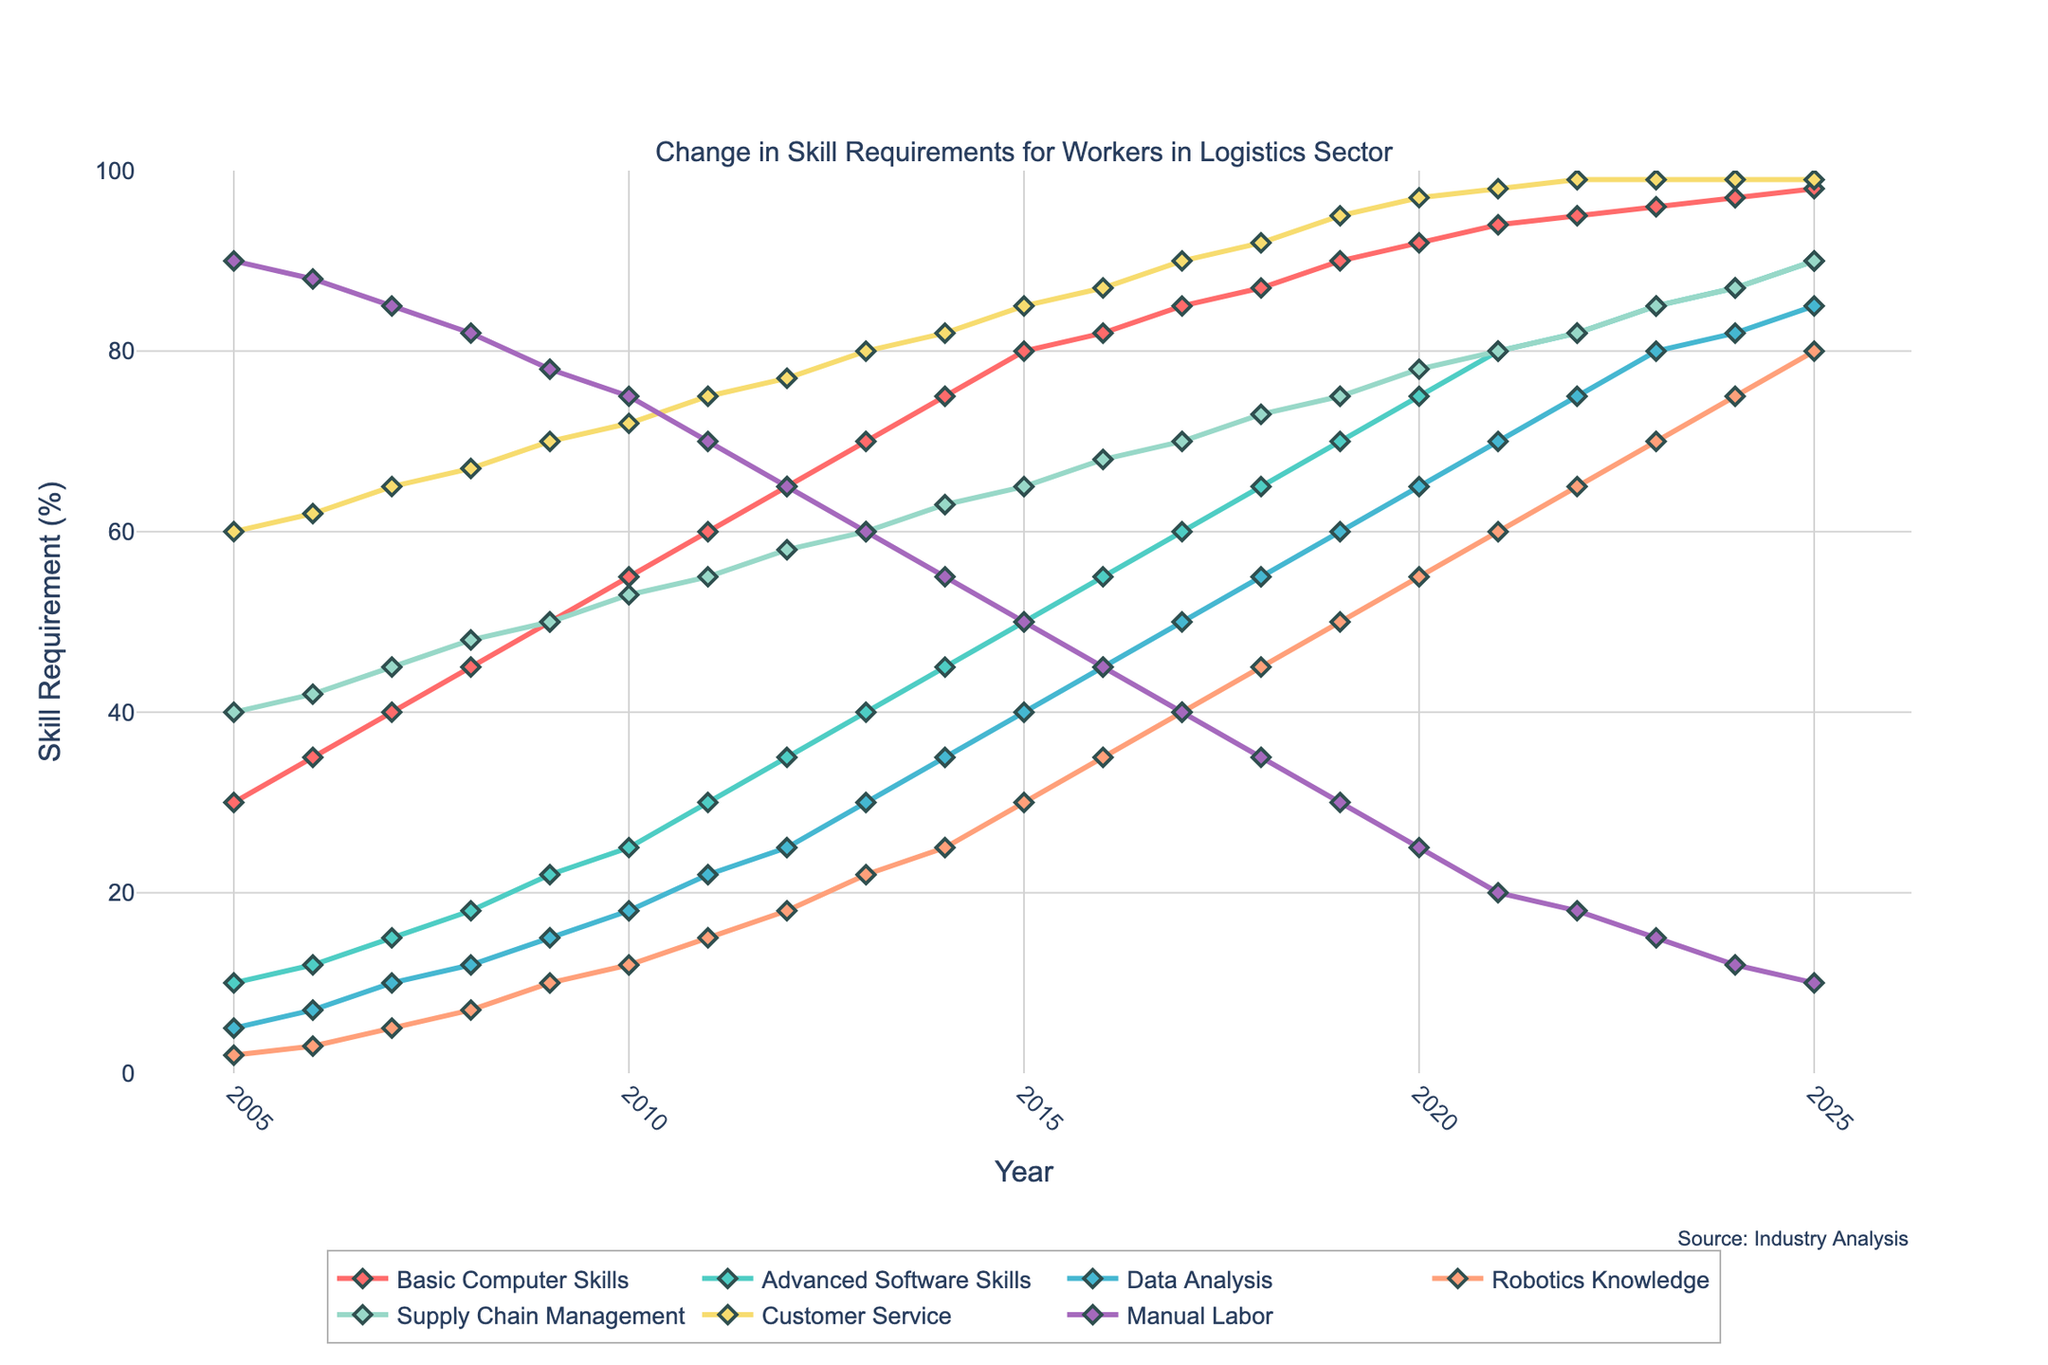What skill showed the most significant increase from 2005 to 2025? By visually inspecting the figure, observe the change in the height of the lines for each skill from 2005 to 2025. The skill with the steepest increase indicates the most significant growth.
Answer: Advanced Software Skills Which skill had the slowest growth in its requirement over the years? Compare the lines for all skills from 2005 to 2025. The line with the smallest overall increase represents the skill with the slowest growth.
Answer: Manual Labor What was the comparative requirement for Advanced Software Skills and Data Analysis in 2010? Check the markers on 2010 for both Advanced Software Skills and Data Analysis. Compare their vertical positions on the y-axis to determine their requirements.
Answer: Advanced Software Skills: 25%, Data Analysis: 18% Which year showed an equal requirement of 99% for Customer Service and Supply Chain Management? Look for the intersection point on the figure where Customer Service and Supply Chain Management have the same value. Check the corresponding year on the x-axis.
Answer: 2023 How much did the requirement for Basic Computer Skills increase from 2005 to 2020? Find the y-values for Basic Computer Skills in 2005 and 2020. Calculate the difference between these values.
Answer: 62% (92 - 30) In which year does Robotics Knowledge first surpass 20%? Observe the values for Robotics Knowledge and check the year when its requirement crosses the 20% mark.
Answer: 2011 What is the average requirement for Supply Chain Management from 2015 to 2020? Sum up the values of Supply Chain Management from 2015 to 2020 and divide by the number of years (6).
Answer: 72.33% Which three skills were most in demand in 2025? Analyze the y-values for all skills in 2025. The three highest values indicate the most in-demand skills.
Answer: Customer Service, Advanced Software Skills, Basic Computer Skills How does the requirement for Manual Labor in 2025 compare to that in 2005? Look at the y-values for Manual Labor in the years 2005 and 2025. Compare these values to find the difference.
Answer: 80% decrease (90 - 10) What trend can you observe for the requirement of Data Analysis from 2005 to 2025? Notice the trajectory of the line for Data Analysis over the years. Describe how its value changes from 2005 to 2025.
Answer: Steady increase 